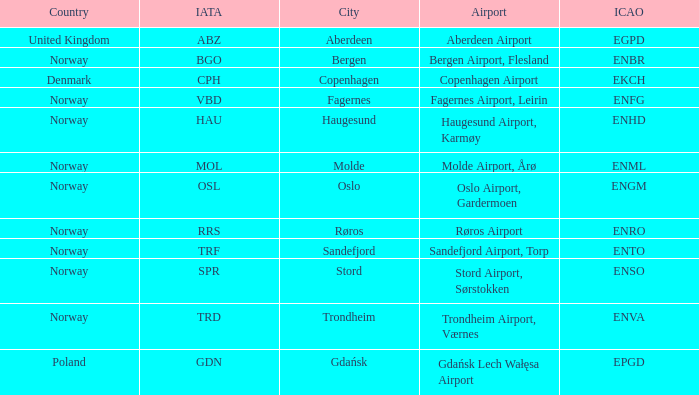Parse the table in full. {'header': ['Country', 'IATA', 'City', 'Airport', 'ICAO'], 'rows': [['United Kingdom', 'ABZ', 'Aberdeen', 'Aberdeen Airport', 'EGPD'], ['Norway', 'BGO', 'Bergen', 'Bergen Airport, Flesland', 'ENBR'], ['Denmark', 'CPH', 'Copenhagen', 'Copenhagen Airport', 'EKCH'], ['Norway', 'VBD', 'Fagernes', 'Fagernes Airport, Leirin', 'ENFG'], ['Norway', 'HAU', 'Haugesund', 'Haugesund Airport, Karmøy', 'ENHD'], ['Norway', 'MOL', 'Molde', 'Molde Airport, Årø', 'ENML'], ['Norway', 'OSL', 'Oslo', 'Oslo Airport, Gardermoen', 'ENGM'], ['Norway', 'RRS', 'Røros', 'Røros Airport', 'ENRO'], ['Norway', 'TRF', 'Sandefjord', 'Sandefjord Airport, Torp', 'ENTO'], ['Norway', 'SPR', 'Stord', 'Stord Airport, Sørstokken', 'ENSO'], ['Norway', 'TRD', 'Trondheim', 'Trondheim Airport, Værnes', 'ENVA'], ['Poland', 'GDN', 'Gdańsk', 'Gdańsk Lech Wałęsa Airport', 'EPGD']]} What Airport's ICAO is ENTO? Sandefjord Airport, Torp. 